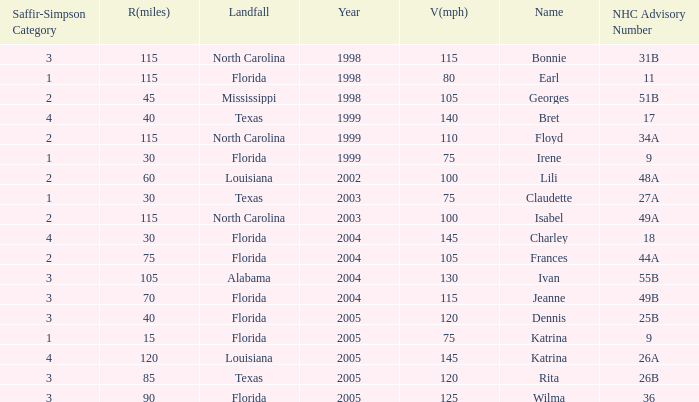What was the lowest V(mph) for a Saffir-Simpson of 4 in 2005? 145.0. 